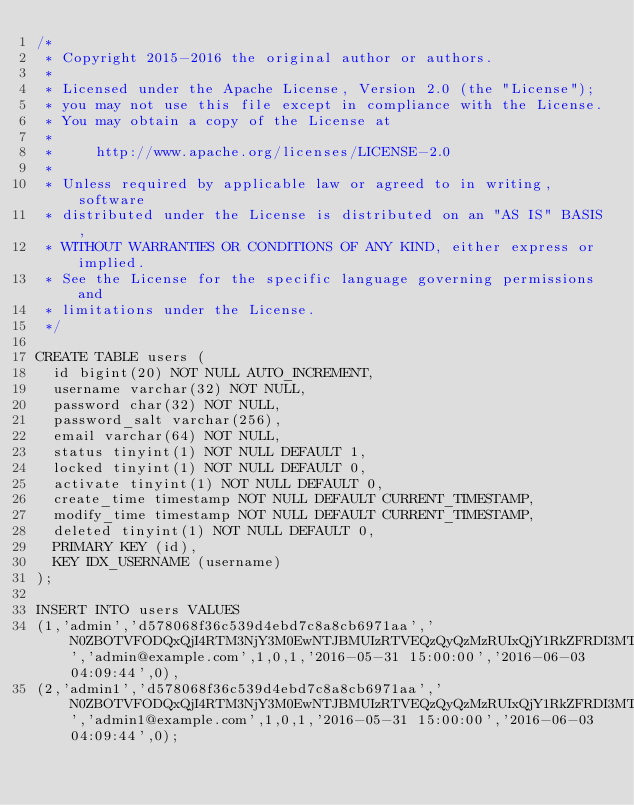<code> <loc_0><loc_0><loc_500><loc_500><_SQL_>/*
 * Copyright 2015-2016 the original author or authors.
 *
 * Licensed under the Apache License, Version 2.0 (the "License");
 * you may not use this file except in compliance with the License.
 * You may obtain a copy of the License at
 *
 *     http://www.apache.org/licenses/LICENSE-2.0
 *
 * Unless required by applicable law or agreed to in writing, software
 * distributed under the License is distributed on an "AS IS" BASIS,
 * WITHOUT WARRANTIES OR CONDITIONS OF ANY KIND, either express or implied.
 * See the License for the specific language governing permissions and
 * limitations under the License.
 */

CREATE TABLE users (
  id bigint(20) NOT NULL AUTO_INCREMENT,
  username varchar(32) NOT NULL,
  password char(32) NOT NULL,
  password_salt varchar(256),
  email varchar(64) NOT NULL,
  status tinyint(1) NOT NULL DEFAULT 1,
  locked tinyint(1) NOT NULL DEFAULT 0,
  activate tinyint(1) NOT NULL DEFAULT 0,
  create_time timestamp NOT NULL DEFAULT CURRENT_TIMESTAMP,
  modify_time timestamp NOT NULL DEFAULT CURRENT_TIMESTAMP,
  deleted tinyint(1) NOT NULL DEFAULT 0,
  PRIMARY KEY (id),
  KEY IDX_USERNAME (username)
);

INSERT INTO users VALUES 
(1,'admin','d578068f36c539d4ebd7c8a8cb6971aa','N0ZBOTVFODQxQjI4RTM3NjY3M0EwNTJBMUIzRTVEQzQyQzMzRUIxQjY1RkZFRDI3MTNCRjcxNUQ2Qjg3MzQyQTY5NjYyRDk1MzZEMUExQjFEQ0I0QzhFQ0VEQzA5RDJC0','admin@example.com',1,0,1,'2016-05-31 15:00:00','2016-06-03 04:09:44',0),
(2,'admin1','d578068f36c539d4ebd7c8a8cb6971aa','N0ZBOTVFODQxQjI4RTM3NjY3M0EwNTJBMUIzRTVEQzQyQzMzRUIxQjY1RkZFRDI3MTNCRjcxNUQ2Qjg3MzQyQTY5NjYyRDk1MzZEMUExQjFEQ0I0QzhFQ0VEQzA5RDJC0','admin1@example.com',1,0,1,'2016-05-31 15:00:00','2016-06-03 04:09:44',0);</code> 